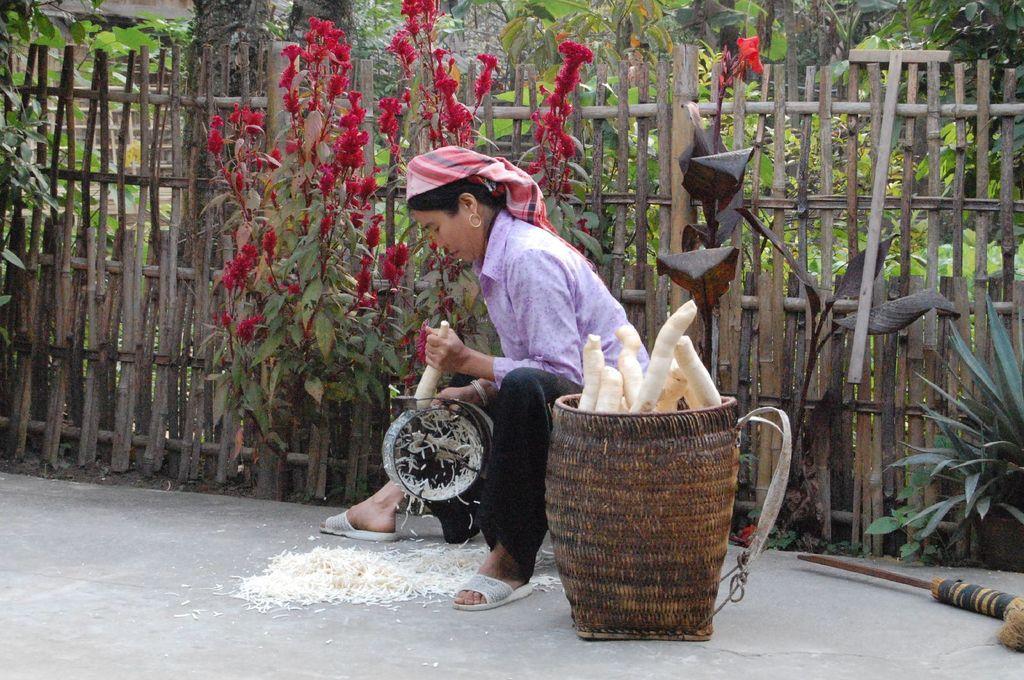Please provide a concise description of this image. There is one woman sitting and holding an object in the middle of this image. We can see fruits are kept in a basket at the bottom of this image. There are plants and a boundary wall in the background. 